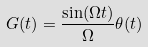Convert formula to latex. <formula><loc_0><loc_0><loc_500><loc_500>G ( t ) = \frac { \sin ( \Omega t ) } { \Omega } \theta ( t )</formula> 